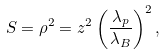Convert formula to latex. <formula><loc_0><loc_0><loc_500><loc_500>S = \rho ^ { 2 } = z ^ { 2 } \left ( \frac { \lambda _ { p } } { \lambda _ { B } } \right ) ^ { 2 } ,</formula> 